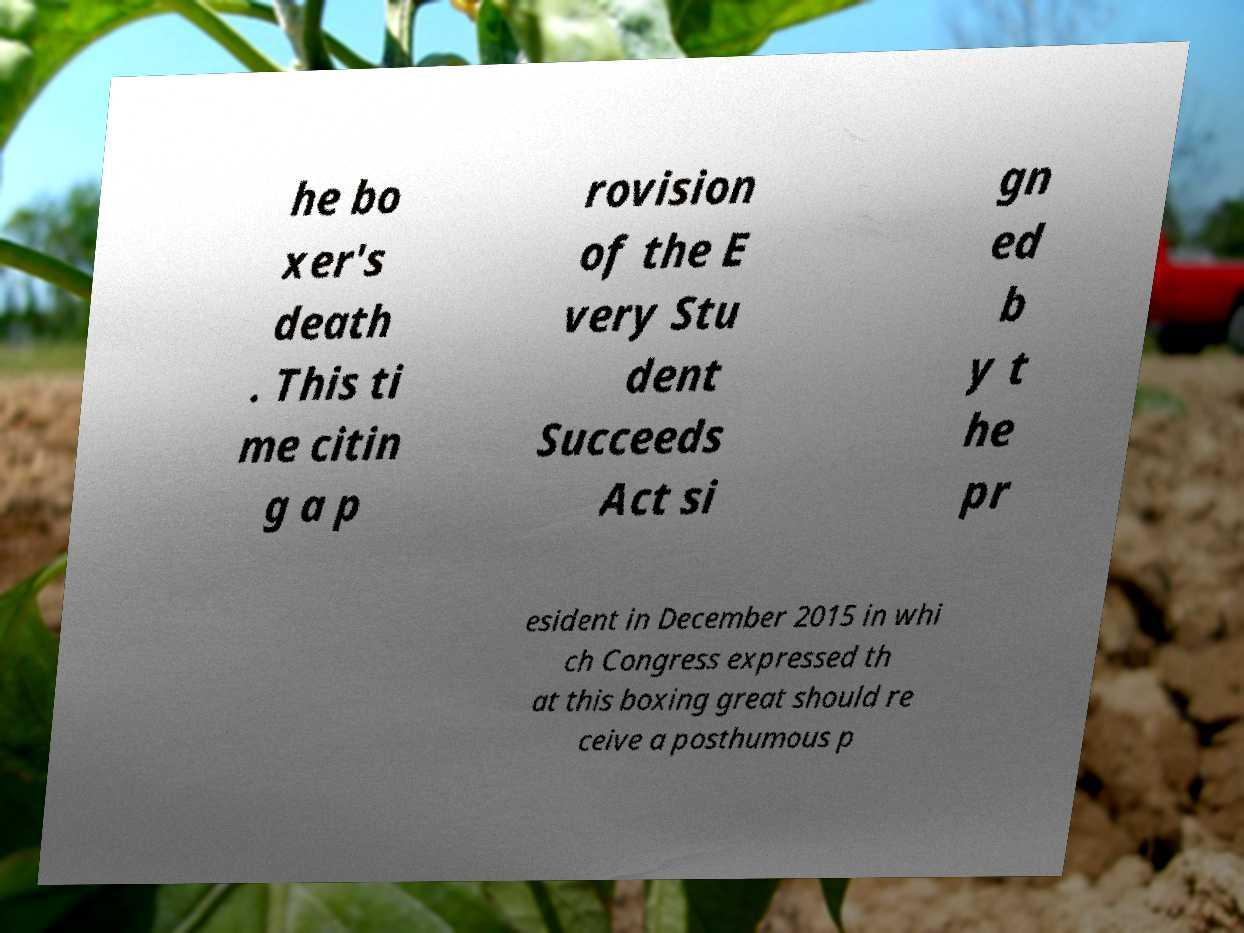For documentation purposes, I need the text within this image transcribed. Could you provide that? he bo xer's death . This ti me citin g a p rovision of the E very Stu dent Succeeds Act si gn ed b y t he pr esident in December 2015 in whi ch Congress expressed th at this boxing great should re ceive a posthumous p 